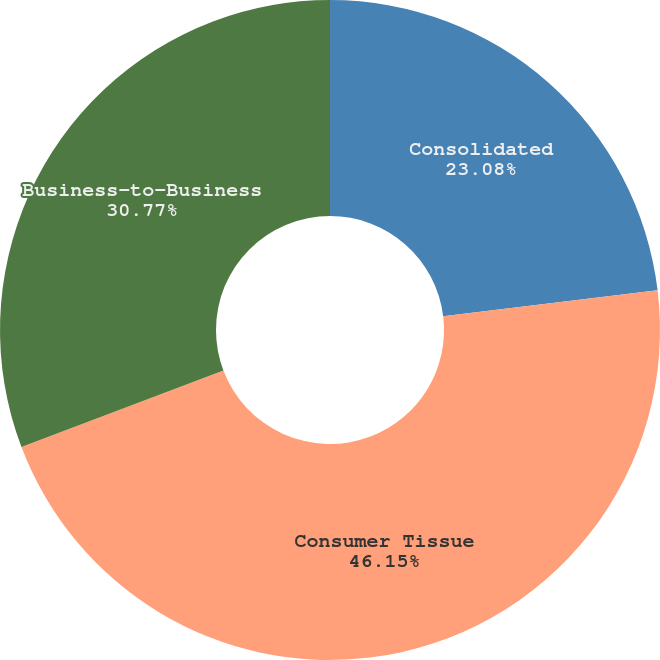Convert chart. <chart><loc_0><loc_0><loc_500><loc_500><pie_chart><fcel>Consolidated<fcel>Consumer Tissue<fcel>Business-to-Business<nl><fcel>23.08%<fcel>46.15%<fcel>30.77%<nl></chart> 